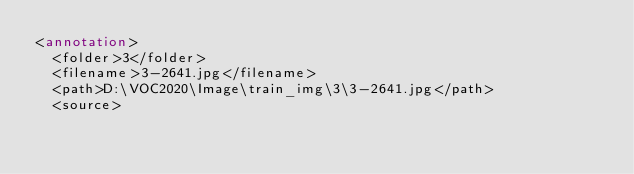Convert code to text. <code><loc_0><loc_0><loc_500><loc_500><_XML_><annotation>
	<folder>3</folder>
	<filename>3-2641.jpg</filename>
	<path>D:\VOC2020\Image\train_img\3\3-2641.jpg</path>
	<source></code> 